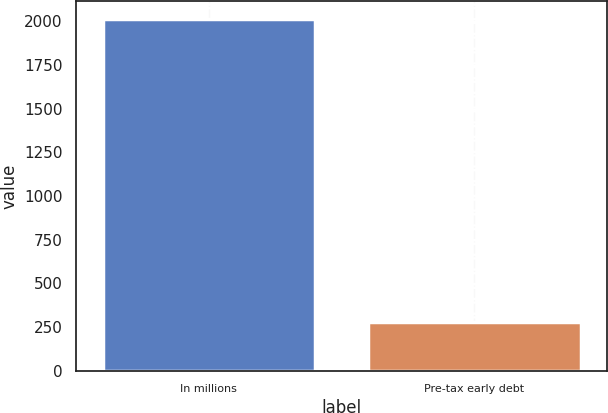<chart> <loc_0><loc_0><loc_500><loc_500><bar_chart><fcel>In millions<fcel>Pre-tax early debt<nl><fcel>2014<fcel>276<nl></chart> 